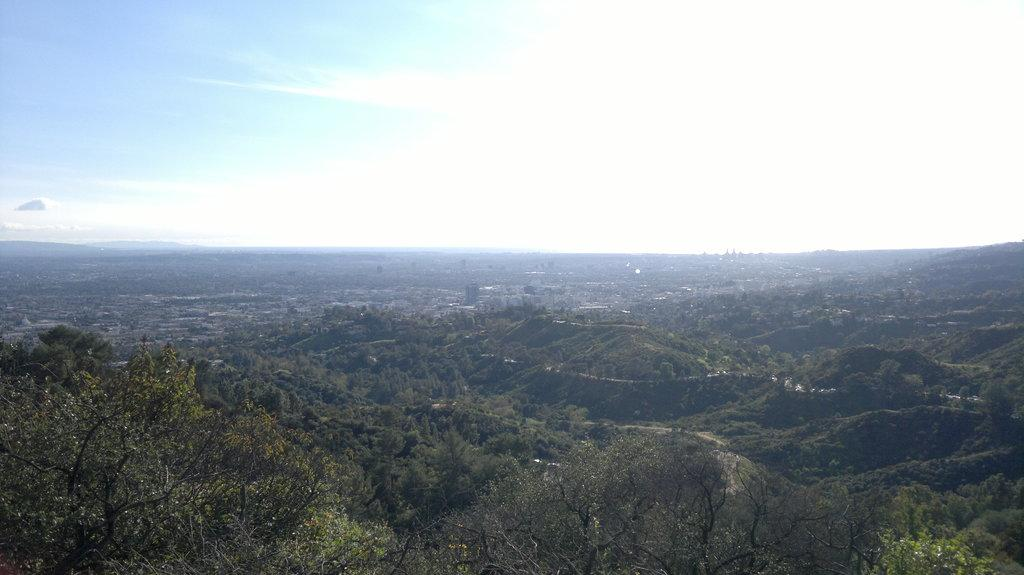What type of natural elements can be seen in the image? There are trees in the image. What type of man-made structures are present in the image? There are buildings in the image. What part of the natural environment is visible in the image? The sky is visible in the image. What atmospheric conditions can be observed in the sky? Clouds are present in the sky. Can you see any ghosts interacting with the trees in the image? There are no ghosts present in the image; it features trees, buildings, and clouds in the sky. What type of bucket is being used to collect rainwater in the image? There is no bucket present in the image. 